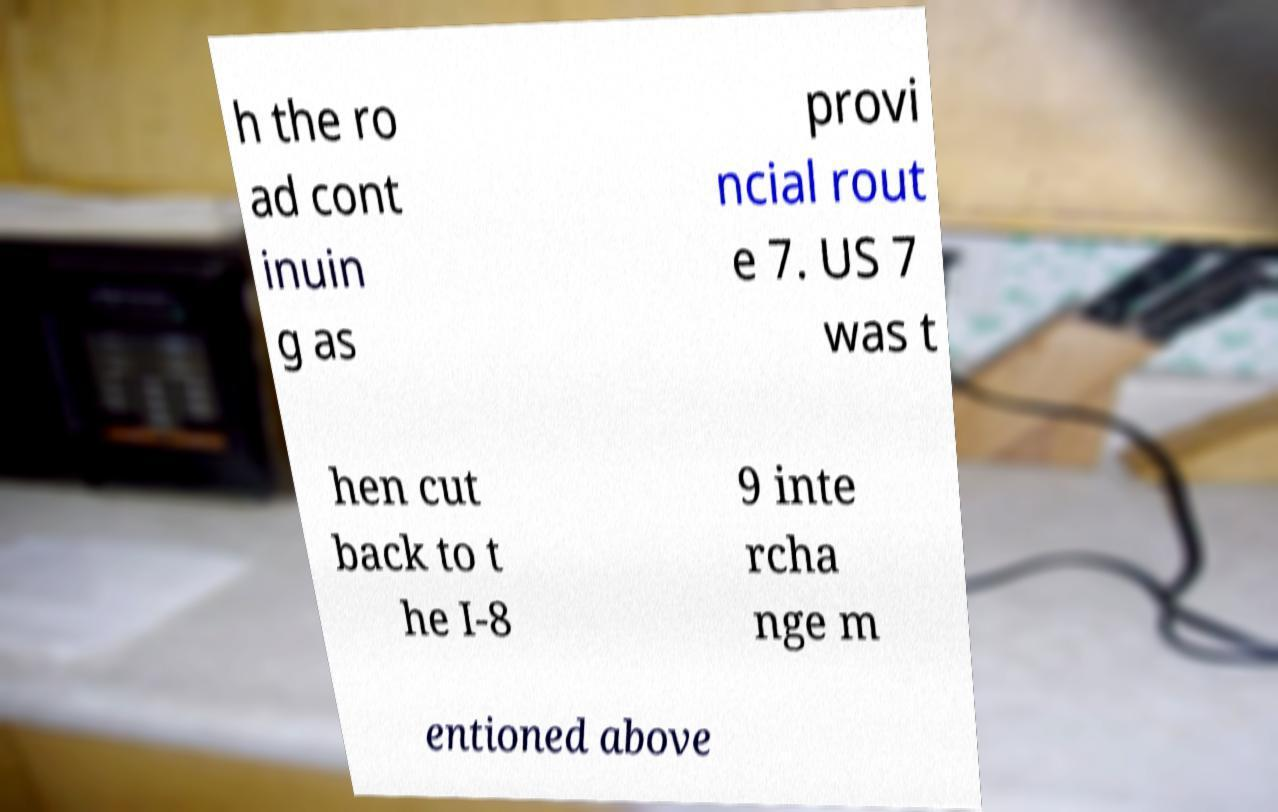There's text embedded in this image that I need extracted. Can you transcribe it verbatim? h the ro ad cont inuin g as provi ncial rout e 7. US 7 was t hen cut back to t he I-8 9 inte rcha nge m entioned above 